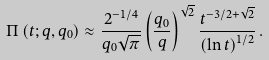<formula> <loc_0><loc_0><loc_500><loc_500>\Pi \left ( t ; q , q _ { 0 } \right ) \approx \frac { 2 ^ { - 1 / 4 } } { q _ { 0 } \sqrt { \pi } } \left ( \frac { q _ { 0 } } q \right ) ^ { \sqrt { 2 } } \frac { t ^ { - 3 / 2 + \sqrt { 2 } } } { \left ( \ln t \right ) ^ { 1 / 2 } } \, .</formula> 